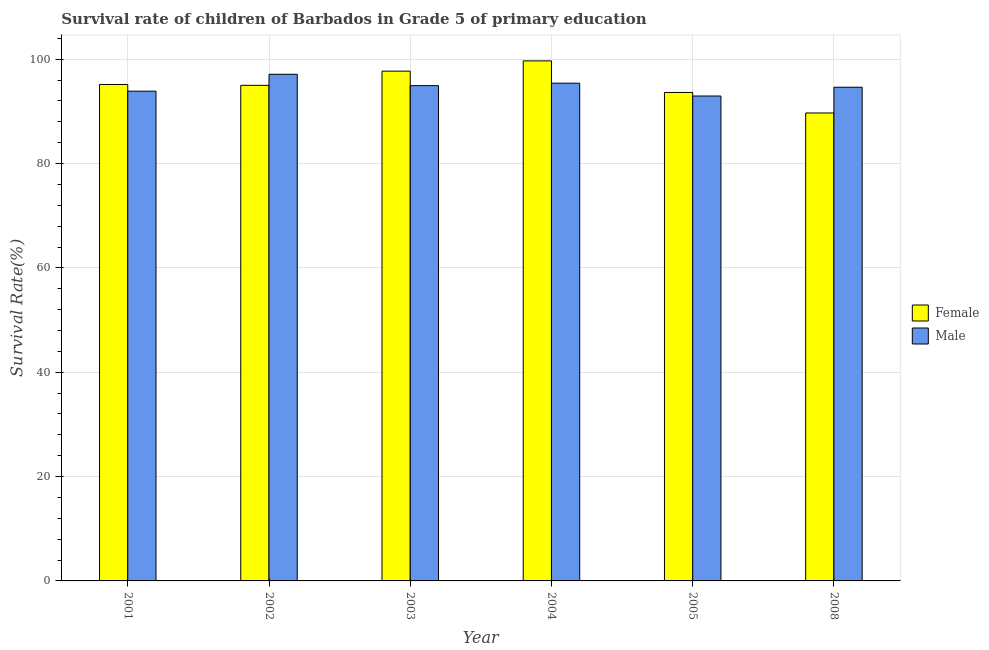How many different coloured bars are there?
Offer a very short reply. 2. Are the number of bars per tick equal to the number of legend labels?
Ensure brevity in your answer.  Yes. Are the number of bars on each tick of the X-axis equal?
Your response must be concise. Yes. What is the label of the 1st group of bars from the left?
Keep it short and to the point. 2001. In how many cases, is the number of bars for a given year not equal to the number of legend labels?
Your response must be concise. 0. What is the survival rate of female students in primary education in 2004?
Keep it short and to the point. 99.67. Across all years, what is the maximum survival rate of male students in primary education?
Offer a very short reply. 97.11. Across all years, what is the minimum survival rate of male students in primary education?
Your response must be concise. 92.94. In which year was the survival rate of male students in primary education maximum?
Make the answer very short. 2002. In which year was the survival rate of male students in primary education minimum?
Your answer should be compact. 2005. What is the total survival rate of male students in primary education in the graph?
Provide a succinct answer. 568.86. What is the difference between the survival rate of male students in primary education in 2003 and that in 2004?
Your answer should be very brief. -0.47. What is the difference between the survival rate of male students in primary education in 2001 and the survival rate of female students in primary education in 2003?
Provide a succinct answer. -1.06. What is the average survival rate of male students in primary education per year?
Ensure brevity in your answer.  94.81. In the year 2003, what is the difference between the survival rate of male students in primary education and survival rate of female students in primary education?
Your response must be concise. 0. What is the ratio of the survival rate of female students in primary education in 2001 to that in 2008?
Your answer should be very brief. 1.06. Is the survival rate of female students in primary education in 2003 less than that in 2005?
Your answer should be compact. No. Is the difference between the survival rate of female students in primary education in 2001 and 2008 greater than the difference between the survival rate of male students in primary education in 2001 and 2008?
Your answer should be very brief. No. What is the difference between the highest and the second highest survival rate of male students in primary education?
Make the answer very short. 1.71. What is the difference between the highest and the lowest survival rate of male students in primary education?
Make the answer very short. 4.16. Is the sum of the survival rate of male students in primary education in 2002 and 2003 greater than the maximum survival rate of female students in primary education across all years?
Your answer should be very brief. Yes. What does the 2nd bar from the left in 2003 represents?
Give a very brief answer. Male. How many bars are there?
Offer a terse response. 12. Are the values on the major ticks of Y-axis written in scientific E-notation?
Your answer should be compact. No. Does the graph contain any zero values?
Offer a terse response. No. Does the graph contain grids?
Your answer should be compact. Yes. Where does the legend appear in the graph?
Provide a short and direct response. Center right. How are the legend labels stacked?
Your answer should be compact. Vertical. What is the title of the graph?
Ensure brevity in your answer.  Survival rate of children of Barbados in Grade 5 of primary education. What is the label or title of the Y-axis?
Ensure brevity in your answer.  Survival Rate(%). What is the Survival Rate(%) of Female in 2001?
Provide a succinct answer. 95.15. What is the Survival Rate(%) of Male in 2001?
Your response must be concise. 93.87. What is the Survival Rate(%) in Female in 2002?
Give a very brief answer. 94.99. What is the Survival Rate(%) of Male in 2002?
Make the answer very short. 97.11. What is the Survival Rate(%) in Female in 2003?
Your response must be concise. 97.71. What is the Survival Rate(%) in Male in 2003?
Make the answer very short. 94.93. What is the Survival Rate(%) of Female in 2004?
Your response must be concise. 99.67. What is the Survival Rate(%) of Male in 2004?
Your answer should be very brief. 95.4. What is the Survival Rate(%) of Female in 2005?
Make the answer very short. 93.62. What is the Survival Rate(%) of Male in 2005?
Keep it short and to the point. 92.94. What is the Survival Rate(%) in Female in 2008?
Offer a very short reply. 89.69. What is the Survival Rate(%) in Male in 2008?
Offer a terse response. 94.62. Across all years, what is the maximum Survival Rate(%) in Female?
Give a very brief answer. 99.67. Across all years, what is the maximum Survival Rate(%) in Male?
Your answer should be very brief. 97.11. Across all years, what is the minimum Survival Rate(%) of Female?
Provide a short and direct response. 89.69. Across all years, what is the minimum Survival Rate(%) in Male?
Ensure brevity in your answer.  92.94. What is the total Survival Rate(%) of Female in the graph?
Offer a terse response. 570.82. What is the total Survival Rate(%) in Male in the graph?
Provide a succinct answer. 568.86. What is the difference between the Survival Rate(%) of Female in 2001 and that in 2002?
Offer a very short reply. 0.16. What is the difference between the Survival Rate(%) in Male in 2001 and that in 2002?
Keep it short and to the point. -3.24. What is the difference between the Survival Rate(%) in Female in 2001 and that in 2003?
Your answer should be very brief. -2.56. What is the difference between the Survival Rate(%) of Male in 2001 and that in 2003?
Ensure brevity in your answer.  -1.06. What is the difference between the Survival Rate(%) in Female in 2001 and that in 2004?
Your answer should be very brief. -4.52. What is the difference between the Survival Rate(%) of Male in 2001 and that in 2004?
Provide a succinct answer. -1.53. What is the difference between the Survival Rate(%) in Female in 2001 and that in 2005?
Give a very brief answer. 1.53. What is the difference between the Survival Rate(%) of Male in 2001 and that in 2005?
Provide a short and direct response. 0.93. What is the difference between the Survival Rate(%) of Female in 2001 and that in 2008?
Your answer should be very brief. 5.46. What is the difference between the Survival Rate(%) in Male in 2001 and that in 2008?
Keep it short and to the point. -0.75. What is the difference between the Survival Rate(%) of Female in 2002 and that in 2003?
Give a very brief answer. -2.72. What is the difference between the Survival Rate(%) of Male in 2002 and that in 2003?
Provide a short and direct response. 2.18. What is the difference between the Survival Rate(%) in Female in 2002 and that in 2004?
Give a very brief answer. -4.69. What is the difference between the Survival Rate(%) of Male in 2002 and that in 2004?
Keep it short and to the point. 1.71. What is the difference between the Survival Rate(%) of Female in 2002 and that in 2005?
Keep it short and to the point. 1.37. What is the difference between the Survival Rate(%) in Male in 2002 and that in 2005?
Provide a short and direct response. 4.16. What is the difference between the Survival Rate(%) of Female in 2002 and that in 2008?
Offer a terse response. 5.3. What is the difference between the Survival Rate(%) in Male in 2002 and that in 2008?
Ensure brevity in your answer.  2.49. What is the difference between the Survival Rate(%) of Female in 2003 and that in 2004?
Provide a succinct answer. -1.97. What is the difference between the Survival Rate(%) of Male in 2003 and that in 2004?
Your answer should be compact. -0.47. What is the difference between the Survival Rate(%) of Female in 2003 and that in 2005?
Your answer should be compact. 4.09. What is the difference between the Survival Rate(%) in Male in 2003 and that in 2005?
Your response must be concise. 1.98. What is the difference between the Survival Rate(%) in Female in 2003 and that in 2008?
Give a very brief answer. 8.02. What is the difference between the Survival Rate(%) in Male in 2003 and that in 2008?
Make the answer very short. 0.3. What is the difference between the Survival Rate(%) of Female in 2004 and that in 2005?
Keep it short and to the point. 6.05. What is the difference between the Survival Rate(%) of Male in 2004 and that in 2005?
Offer a terse response. 2.46. What is the difference between the Survival Rate(%) of Female in 2004 and that in 2008?
Give a very brief answer. 9.99. What is the difference between the Survival Rate(%) in Male in 2004 and that in 2008?
Provide a succinct answer. 0.78. What is the difference between the Survival Rate(%) in Female in 2005 and that in 2008?
Offer a very short reply. 3.93. What is the difference between the Survival Rate(%) in Male in 2005 and that in 2008?
Make the answer very short. -1.68. What is the difference between the Survival Rate(%) in Female in 2001 and the Survival Rate(%) in Male in 2002?
Your answer should be compact. -1.96. What is the difference between the Survival Rate(%) of Female in 2001 and the Survival Rate(%) of Male in 2003?
Keep it short and to the point. 0.22. What is the difference between the Survival Rate(%) of Female in 2001 and the Survival Rate(%) of Male in 2004?
Ensure brevity in your answer.  -0.25. What is the difference between the Survival Rate(%) in Female in 2001 and the Survival Rate(%) in Male in 2005?
Your response must be concise. 2.21. What is the difference between the Survival Rate(%) in Female in 2001 and the Survival Rate(%) in Male in 2008?
Provide a short and direct response. 0.53. What is the difference between the Survival Rate(%) of Female in 2002 and the Survival Rate(%) of Male in 2003?
Your answer should be compact. 0.06. What is the difference between the Survival Rate(%) of Female in 2002 and the Survival Rate(%) of Male in 2004?
Provide a short and direct response. -0.41. What is the difference between the Survival Rate(%) in Female in 2002 and the Survival Rate(%) in Male in 2005?
Give a very brief answer. 2.04. What is the difference between the Survival Rate(%) in Female in 2002 and the Survival Rate(%) in Male in 2008?
Offer a very short reply. 0.36. What is the difference between the Survival Rate(%) of Female in 2003 and the Survival Rate(%) of Male in 2004?
Offer a terse response. 2.31. What is the difference between the Survival Rate(%) in Female in 2003 and the Survival Rate(%) in Male in 2005?
Give a very brief answer. 4.76. What is the difference between the Survival Rate(%) of Female in 2003 and the Survival Rate(%) of Male in 2008?
Ensure brevity in your answer.  3.08. What is the difference between the Survival Rate(%) in Female in 2004 and the Survival Rate(%) in Male in 2005?
Make the answer very short. 6.73. What is the difference between the Survival Rate(%) in Female in 2004 and the Survival Rate(%) in Male in 2008?
Give a very brief answer. 5.05. What is the difference between the Survival Rate(%) of Female in 2005 and the Survival Rate(%) of Male in 2008?
Keep it short and to the point. -1. What is the average Survival Rate(%) of Female per year?
Offer a very short reply. 95.14. What is the average Survival Rate(%) of Male per year?
Your answer should be very brief. 94.81. In the year 2001, what is the difference between the Survival Rate(%) of Female and Survival Rate(%) of Male?
Offer a terse response. 1.28. In the year 2002, what is the difference between the Survival Rate(%) of Female and Survival Rate(%) of Male?
Your response must be concise. -2.12. In the year 2003, what is the difference between the Survival Rate(%) in Female and Survival Rate(%) in Male?
Offer a very short reply. 2.78. In the year 2004, what is the difference between the Survival Rate(%) of Female and Survival Rate(%) of Male?
Ensure brevity in your answer.  4.28. In the year 2005, what is the difference between the Survival Rate(%) in Female and Survival Rate(%) in Male?
Your response must be concise. 0.68. In the year 2008, what is the difference between the Survival Rate(%) in Female and Survival Rate(%) in Male?
Your response must be concise. -4.93. What is the ratio of the Survival Rate(%) in Male in 2001 to that in 2002?
Your answer should be very brief. 0.97. What is the ratio of the Survival Rate(%) in Female in 2001 to that in 2003?
Your answer should be very brief. 0.97. What is the ratio of the Survival Rate(%) of Male in 2001 to that in 2003?
Give a very brief answer. 0.99. What is the ratio of the Survival Rate(%) of Female in 2001 to that in 2004?
Provide a succinct answer. 0.95. What is the ratio of the Survival Rate(%) in Female in 2001 to that in 2005?
Your answer should be compact. 1.02. What is the ratio of the Survival Rate(%) of Male in 2001 to that in 2005?
Offer a very short reply. 1.01. What is the ratio of the Survival Rate(%) in Female in 2001 to that in 2008?
Make the answer very short. 1.06. What is the ratio of the Survival Rate(%) in Female in 2002 to that in 2003?
Provide a succinct answer. 0.97. What is the ratio of the Survival Rate(%) of Female in 2002 to that in 2004?
Give a very brief answer. 0.95. What is the ratio of the Survival Rate(%) in Male in 2002 to that in 2004?
Keep it short and to the point. 1.02. What is the ratio of the Survival Rate(%) in Female in 2002 to that in 2005?
Your answer should be compact. 1.01. What is the ratio of the Survival Rate(%) of Male in 2002 to that in 2005?
Offer a terse response. 1.04. What is the ratio of the Survival Rate(%) of Female in 2002 to that in 2008?
Make the answer very short. 1.06. What is the ratio of the Survival Rate(%) in Male in 2002 to that in 2008?
Offer a terse response. 1.03. What is the ratio of the Survival Rate(%) in Female in 2003 to that in 2004?
Your response must be concise. 0.98. What is the ratio of the Survival Rate(%) of Male in 2003 to that in 2004?
Provide a succinct answer. 0.99. What is the ratio of the Survival Rate(%) of Female in 2003 to that in 2005?
Make the answer very short. 1.04. What is the ratio of the Survival Rate(%) of Male in 2003 to that in 2005?
Make the answer very short. 1.02. What is the ratio of the Survival Rate(%) in Female in 2003 to that in 2008?
Ensure brevity in your answer.  1.09. What is the ratio of the Survival Rate(%) in Female in 2004 to that in 2005?
Your response must be concise. 1.06. What is the ratio of the Survival Rate(%) of Male in 2004 to that in 2005?
Provide a short and direct response. 1.03. What is the ratio of the Survival Rate(%) in Female in 2004 to that in 2008?
Give a very brief answer. 1.11. What is the ratio of the Survival Rate(%) of Male in 2004 to that in 2008?
Provide a short and direct response. 1.01. What is the ratio of the Survival Rate(%) of Female in 2005 to that in 2008?
Offer a very short reply. 1.04. What is the ratio of the Survival Rate(%) in Male in 2005 to that in 2008?
Your answer should be compact. 0.98. What is the difference between the highest and the second highest Survival Rate(%) in Female?
Your response must be concise. 1.97. What is the difference between the highest and the second highest Survival Rate(%) of Male?
Keep it short and to the point. 1.71. What is the difference between the highest and the lowest Survival Rate(%) of Female?
Your response must be concise. 9.99. What is the difference between the highest and the lowest Survival Rate(%) in Male?
Your answer should be very brief. 4.16. 